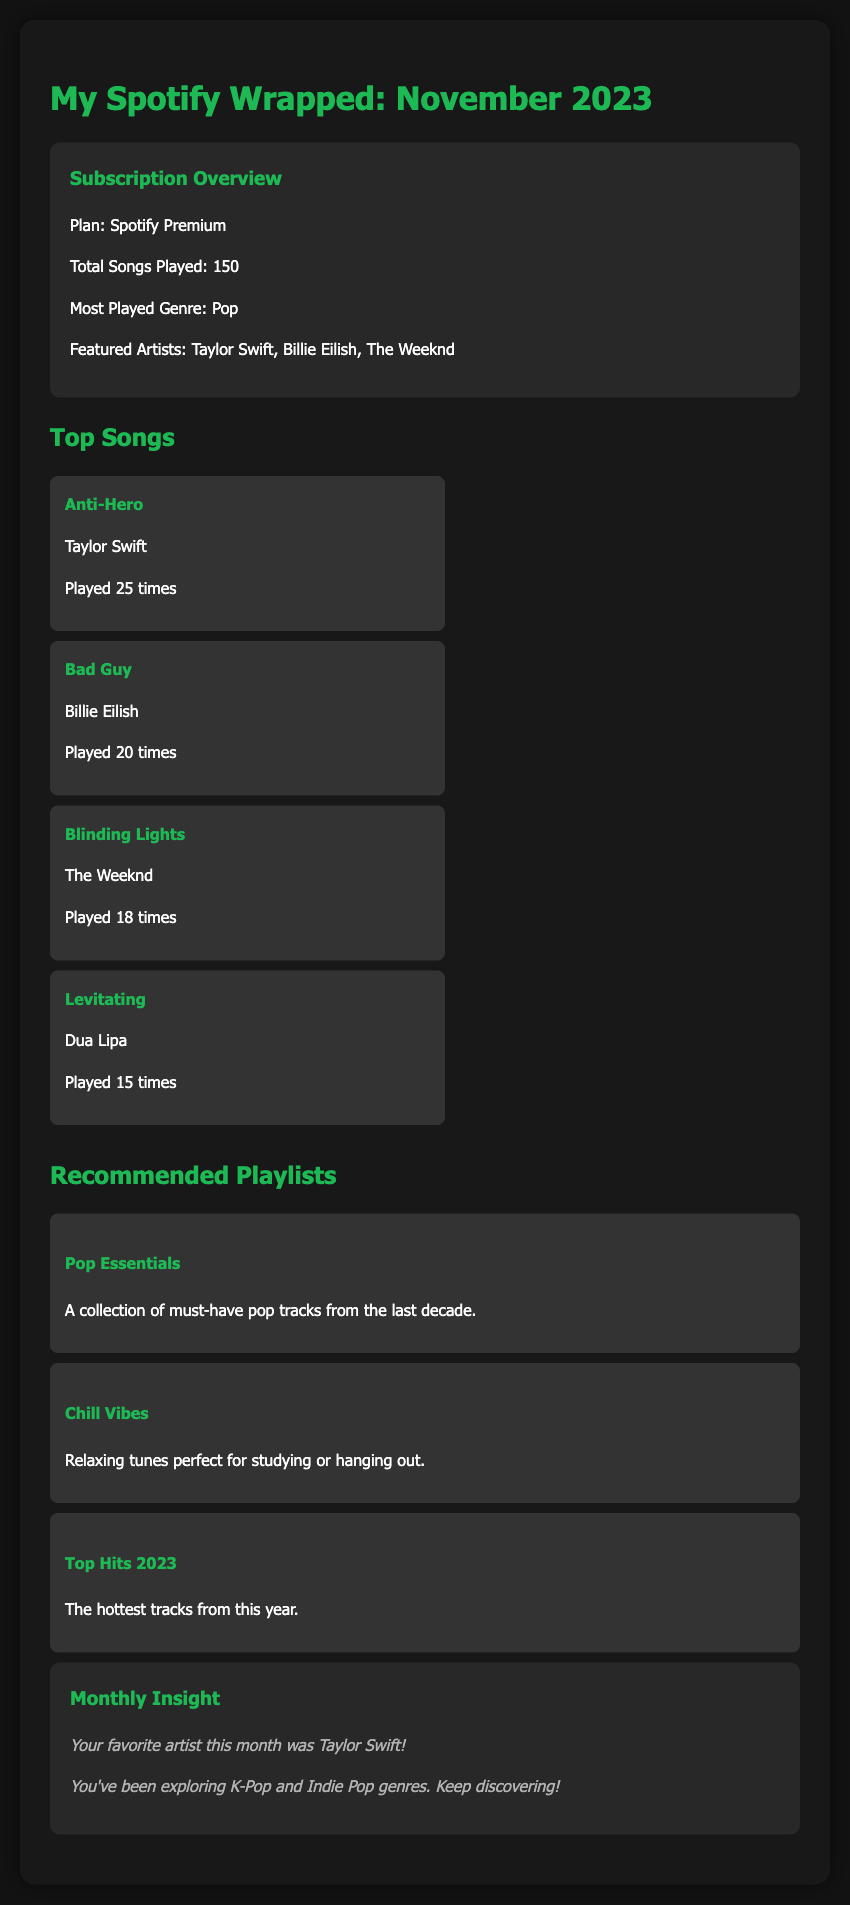what is the total number of songs played? The total number of songs played is clearly stated in the subscription overview section.
Answer: 150 what is the most played genre? The most played genre is mentioned in the subscription overview section.
Answer: Pop who is the featured artist with the highest play count? The featured artist mentioned in the top songs section with the highest play count is Taylor Swift.
Answer: Taylor Swift how many times was "Bad Guy" played? The number of times "Bad Guy" was played is specified in the top songs list.
Answer: 20 times which playlist includes must-have pop tracks? The playlist described as a collection of must-have pop tracks is identified in the recommended playlists section.
Answer: Pop Essentials who was your favorite artist this month? The favorite artist for the month is highlighted in the monthly insight section.
Answer: Taylor Swift how many songs does the "Chill Vibes" playlist feature? The specific number of songs in the "Chill Vibes" playlist is not mentioned, but it can be inferred that it includes relaxing tunes.
Answer: Not specified what genre have you been exploring this month? The genres being explored are mentioned in the monthly insight section.
Answer: K-Pop and Indie Pop how many times was "Blinding Lights" played? The number of times "Blinding Lights" was played is specified in the top songs list.
Answer: 18 times 